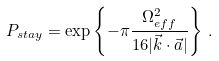Convert formula to latex. <formula><loc_0><loc_0><loc_500><loc_500>P _ { s t a y } = \exp \left \{ - \pi \frac { \Omega _ { e f f } ^ { 2 } } { 1 6 | \vec { k } \cdot \vec { a } | } \right \} \, .</formula> 